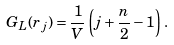Convert formula to latex. <formula><loc_0><loc_0><loc_500><loc_500>G _ { L } ( r _ { j } ) = \frac { 1 } { V } \left ( j + \frac { n } { 2 } - 1 \right ) \, .</formula> 